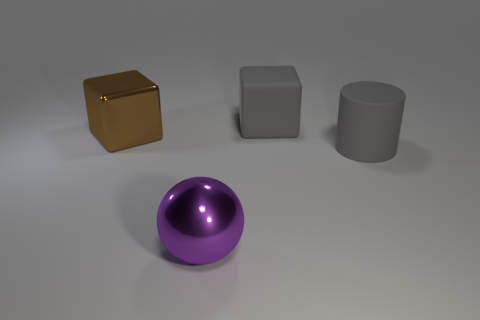Does the image imply anything about the relative weight of the objects? From the image alone, without any context on the material composition of the objects, it's challenging to ascertain the relative weights definitively. The objects themselves do not bend or deform the surface they are on, indicating they might be relatively lightweight or the surface could be solid and supportive.  Are there indications of function or purpose for these objects? The image appears to be more of a composition experiment than a depiction of functional items. With no contextual elements like human interaction or additional environment, it's not clear if these objects serve a particular purpose beyond their geometric illustrative value. 